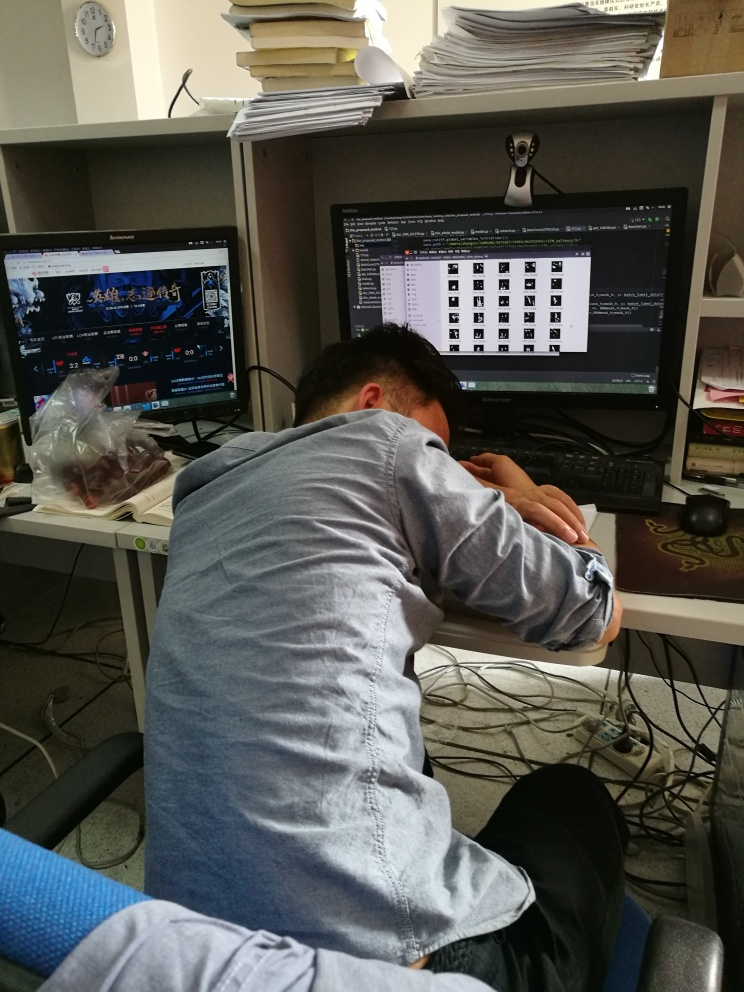Can you describe the mood of the setting in this image? The image depicts a workplace setting with a somewhat chaotic and possibly stressful atmosphere. The presence of multiple computer screens, one displaying a gaming website, and another showing a list of files, alongside a person resting their head on the desk, suggests a juxtaposition of work and leisure, or perhaps an attempt at taking a break from the demands of the job. What suggestions would you have for improving this workspace to reduce stress and increase productivity? To create a more conducive work environment, first declutter the workspace to reduce visual stress. Organize papers into trays or drawers. Adjust the lighting for comfort, and if possible, have a source of natural light. Consider ergonomics, such as a supportive chair and proper monitor height, to prevent strain. Introduce a few plants for a touch of nature which can be calming. Lastly, a clear separation of work and leisure areas could help in maintaining focus while at the desk. 